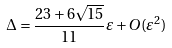Convert formula to latex. <formula><loc_0><loc_0><loc_500><loc_500>\Delta = \frac { 2 3 + 6 \sqrt { 1 5 } } { 1 1 } \varepsilon + O ( \varepsilon ^ { 2 } ) \,</formula> 